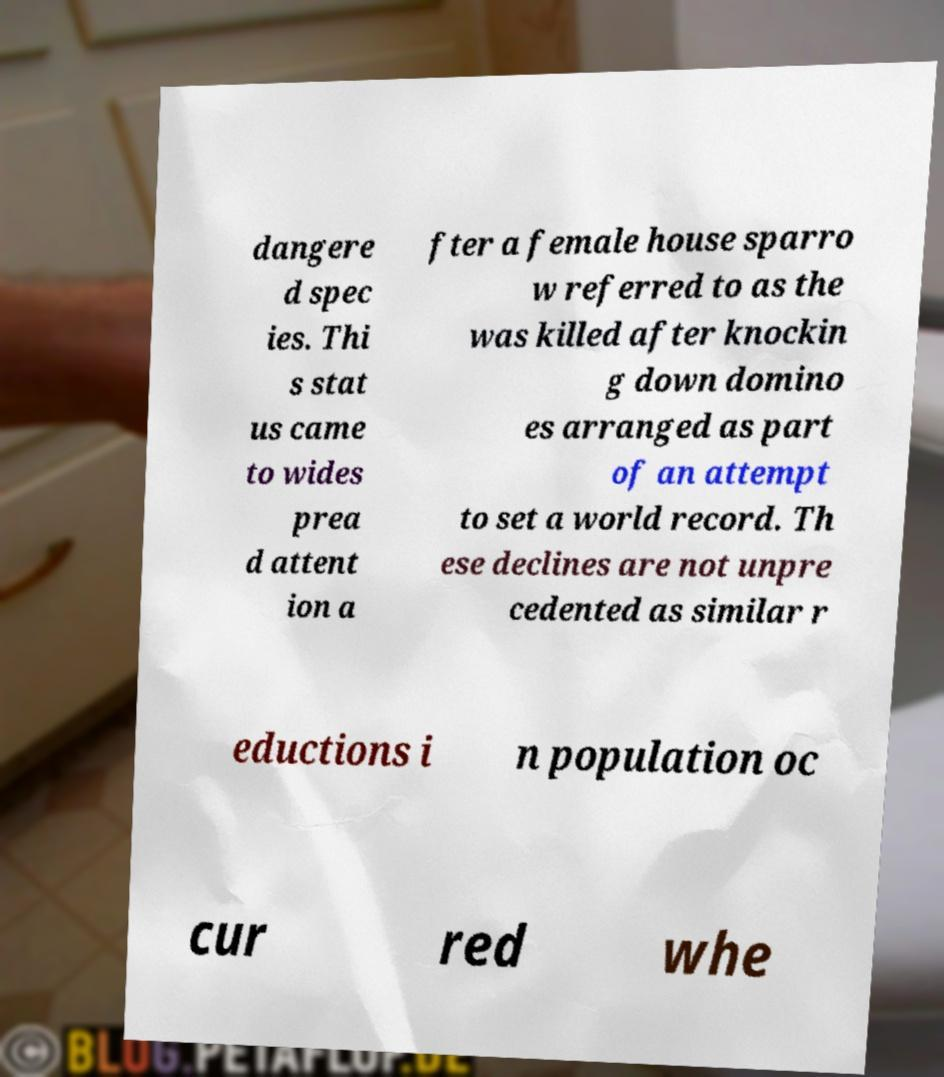Could you assist in decoding the text presented in this image and type it out clearly? dangere d spec ies. Thi s stat us came to wides prea d attent ion a fter a female house sparro w referred to as the was killed after knockin g down domino es arranged as part of an attempt to set a world record. Th ese declines are not unpre cedented as similar r eductions i n population oc cur red whe 